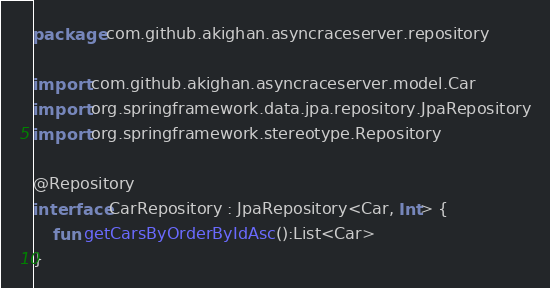Convert code to text. <code><loc_0><loc_0><loc_500><loc_500><_Kotlin_>package com.github.akighan.asyncraceserver.repository

import com.github.akighan.asyncraceserver.model.Car
import org.springframework.data.jpa.repository.JpaRepository
import org.springframework.stereotype.Repository

@Repository
interface CarRepository : JpaRepository<Car, Int> {
    fun getCarsByOrderByIdAsc():List<Car>
}
</code> 